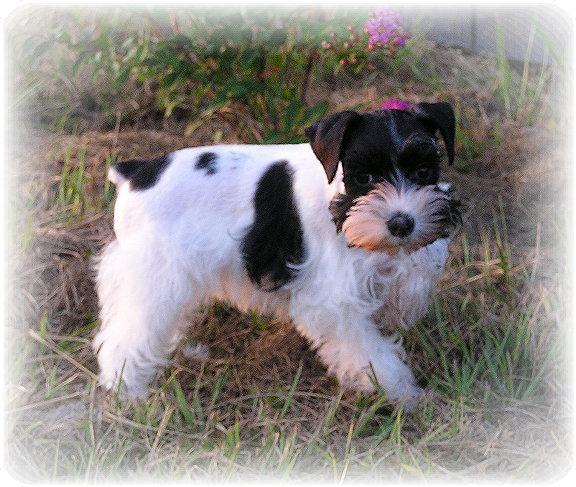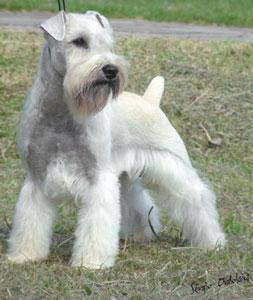The first image is the image on the left, the second image is the image on the right. Given the left and right images, does the statement "At least one dog is standing on grass." hold true? Answer yes or no. Yes. The first image is the image on the left, the second image is the image on the right. Evaluate the accuracy of this statement regarding the images: "a black and white dog is standing in the grass looking at the camera". Is it true? Answer yes or no. Yes. 